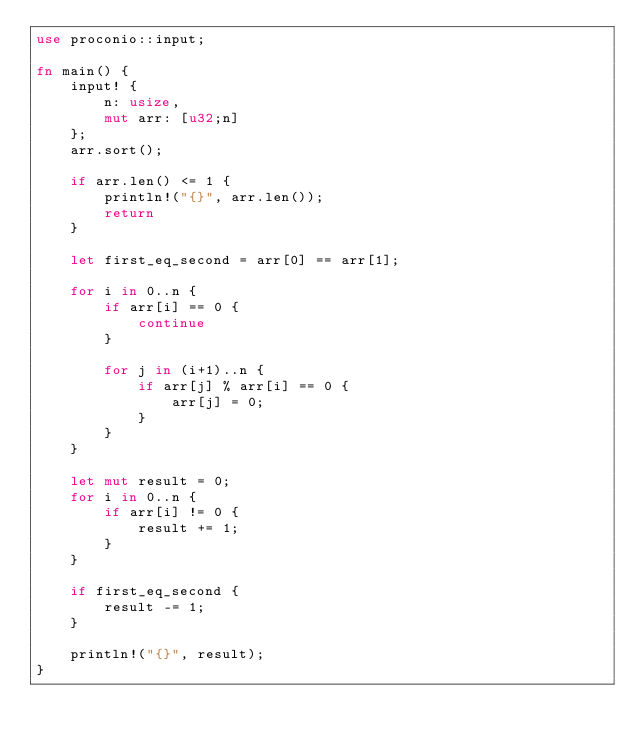<code> <loc_0><loc_0><loc_500><loc_500><_Rust_>use proconio::input;

fn main() {
    input! {
      	n: usize,
      	mut arr: [u32;n]
    };
  	arr.sort();
  
  	if arr.len() <= 1 {
      	println!("{}", arr.len());
  		return
  	}
  
  	let first_eq_second = arr[0] == arr[1];
  
  	for i in 0..n {
      	if arr[i] == 0 {
      		continue
      	}

  		for j in (i+1)..n {
          	if arr[j] % arr[i] == 0 {
          		arr[j] = 0;
          	}
      	}
  	}

  	let mut result = 0;
	for i in 0..n {
      	if arr[i] != 0 {
      		result += 1;
      	}
  	}
  
  	if first_eq_second {
     	result -= 1; 
  	}

    println!("{}", result);
}</code> 